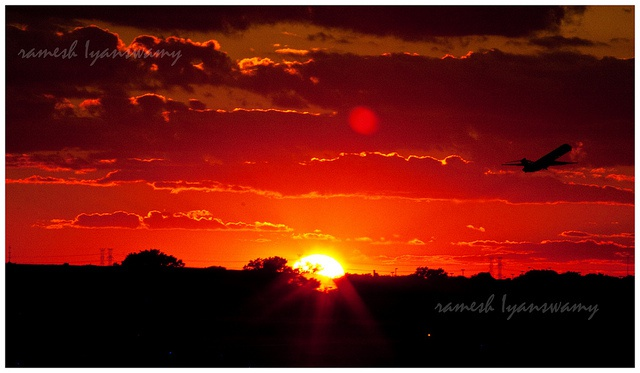Describe the objects in this image and their specific colors. I can see a airplane in maroon, black, and white tones in this image. 